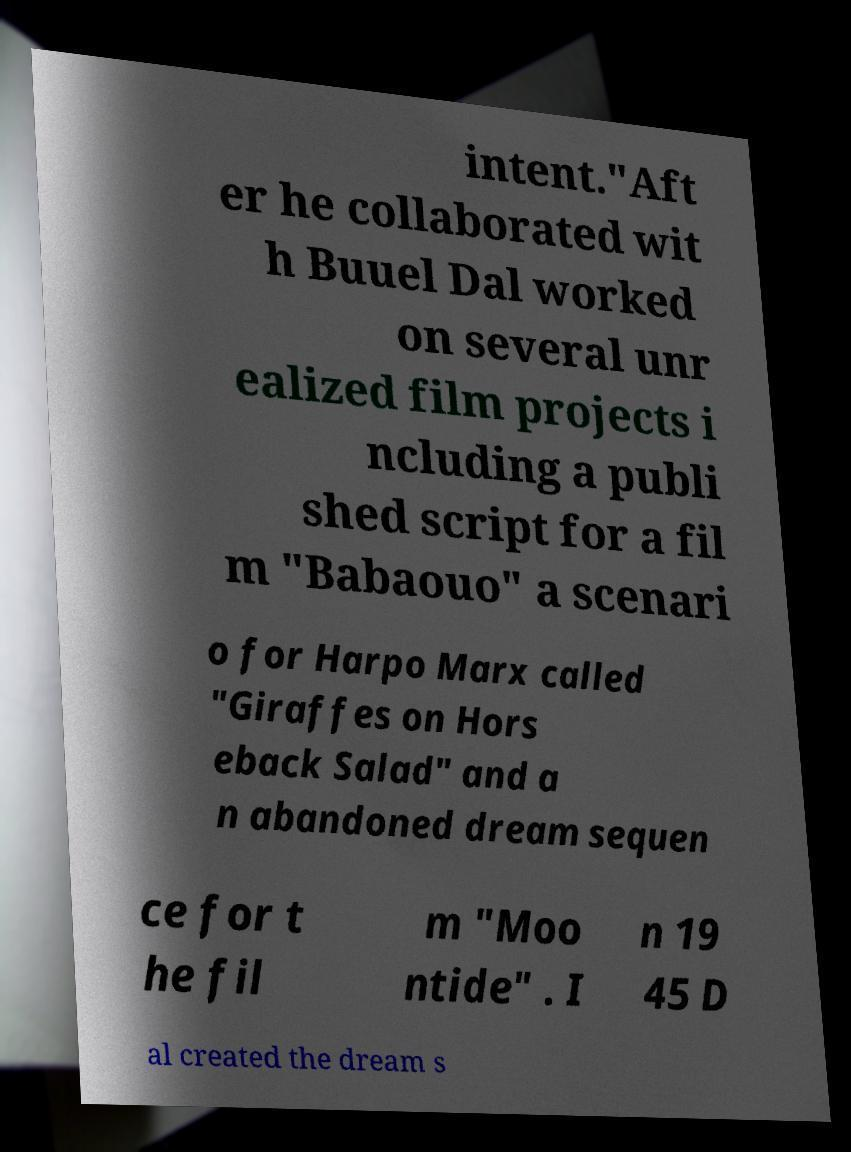There's text embedded in this image that I need extracted. Can you transcribe it verbatim? intent."Aft er he collaborated wit h Buuel Dal worked on several unr ealized film projects i ncluding a publi shed script for a fil m "Babaouo" a scenari o for Harpo Marx called "Giraffes on Hors eback Salad" and a n abandoned dream sequen ce for t he fil m "Moo ntide" . I n 19 45 D al created the dream s 